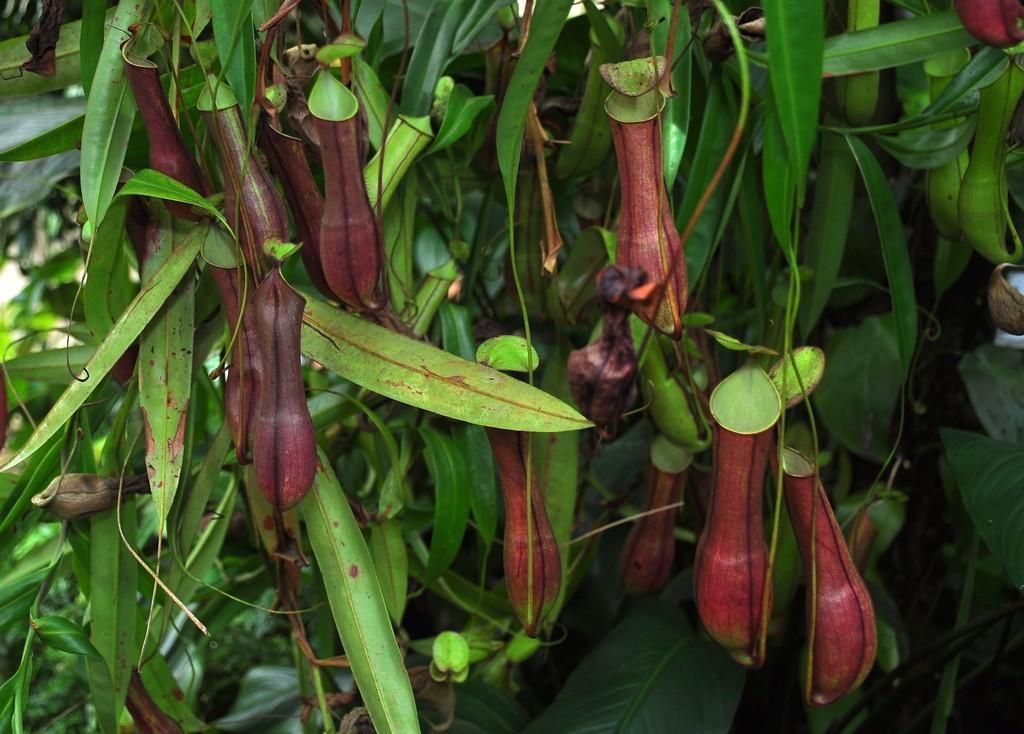Please provide a concise description of this image. In the foreground of the picture there are trees. The background is blurred. 